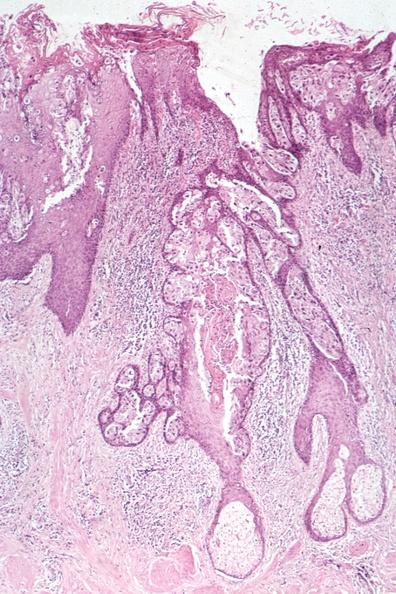s fibrinous peritonitis a quite good example of pagets disease?
Answer the question using a single word or phrase. No 